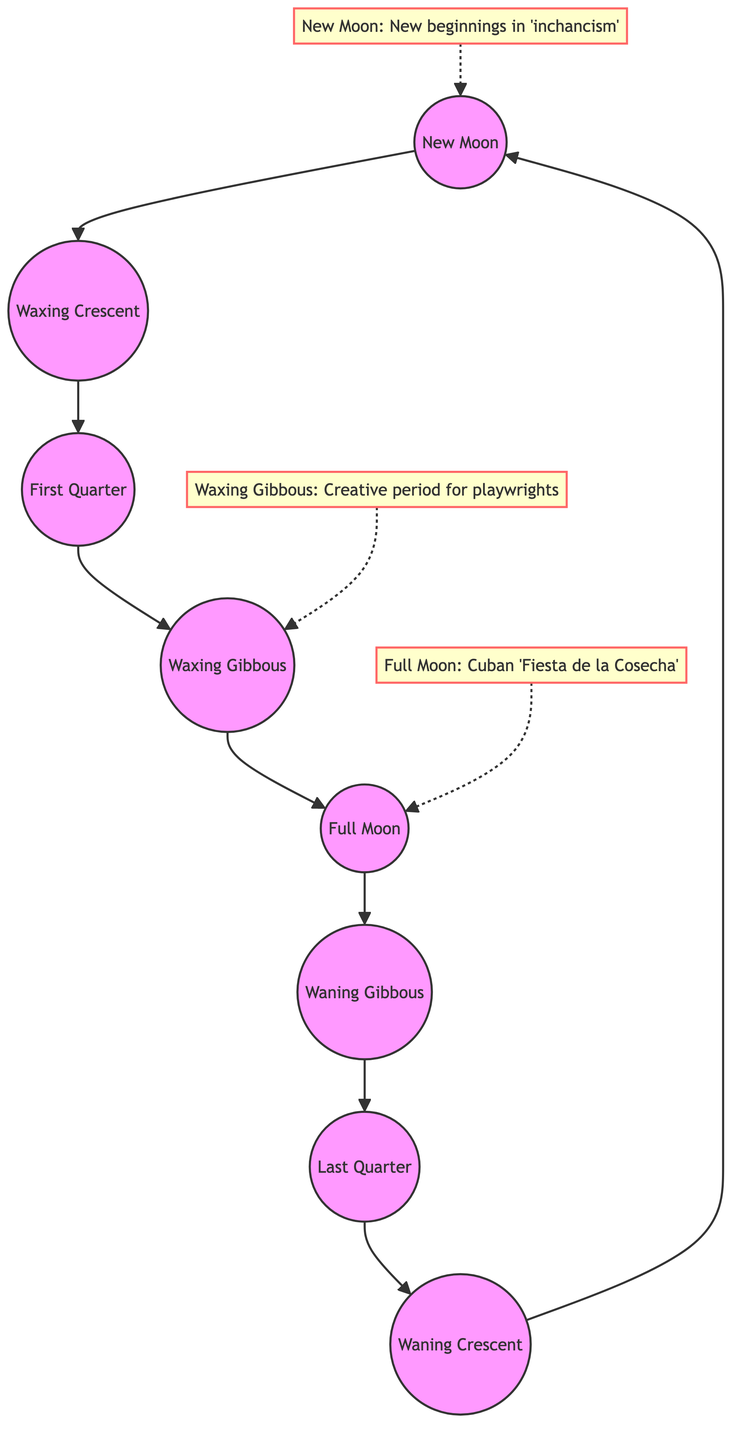What is the first phase of the moon in the cycle? The diagram starts with the "New Moon" which is the first node in the flow of the phases. This indicates that the moon cycle begins with the New Moon phase.
Answer: New Moon How many phases of the moon are shown in the diagram? The diagram lists eight distinct phases of the moon: New Moon, Waxing Crescent, First Quarter, Waxing Gibbous, Full Moon, Waning Gibbous, Last Quarter, and Waning Crescent. Counting these gives a total of eight phases.
Answer: 8 What cultural reference is associated with the Full Moon? The diagram states that the Full Moon is linked to the "Cuban 'Fiesta de la Cosecha'," which means this cultural event is highlighted at this phase.
Answer: Cuban 'Fiesta de la Cosecha' What follows the Waxing Gibbous in the moon phase cycle? According to the flow of the diagram, "Full Moon" comes directly after "Waxing Gibbous." Thus, this is the next phase in the sequence.
Answer: Full Moon In which phase is creativity emphasized for playwrights? The diagram indicates that the "Waxing Gibbous" phase is a creative period for playwrights, showcasing this cultural insight.
Answer: Waxing Gibbous What is the last phase of the moon before returning to New Moon? The diagram identifies the "Waning Crescent" as the last phase before the cycle restarts with the New Moon. Following the flow, you see it ends with this phase.
Answer: Waning Crescent How many cultural references are mentioned in the diagram? There are three cultural references noted: one for New Moon, one for Full Moon, and one for Waxing Gibbous. Summing these gives a total of three cultural insights within the diagram.
Answer: 3 Which phase is directly connected to the 'New beginnings in inchancism'? The diagram connects the "New Moon" to the cultural reference indicating new beginnings in 'inchancism,' positioning it as the node related to that cultural belief.
Answer: New Moon What is the relationship between the Full Moon and the Waxing Gibbous phases? The diagram shows that "Waxing Gibbous" leads directly to the "Full Moon," indicating a sequential relationship where Waxing Gibbous is a precursor to Full Moon in the cycle.
Answer: Waxing Gibbous to Full Moon 